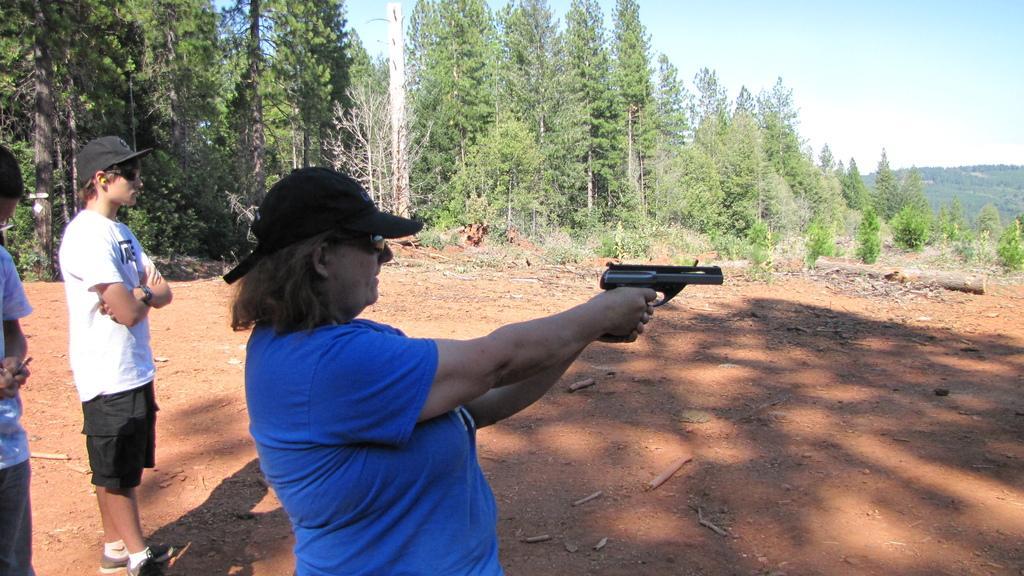Can you describe this image briefly? In this image, we can see a person standing and holding a gun, there are two persons standing, we can see some plants and trees, at the top there is a sky. 